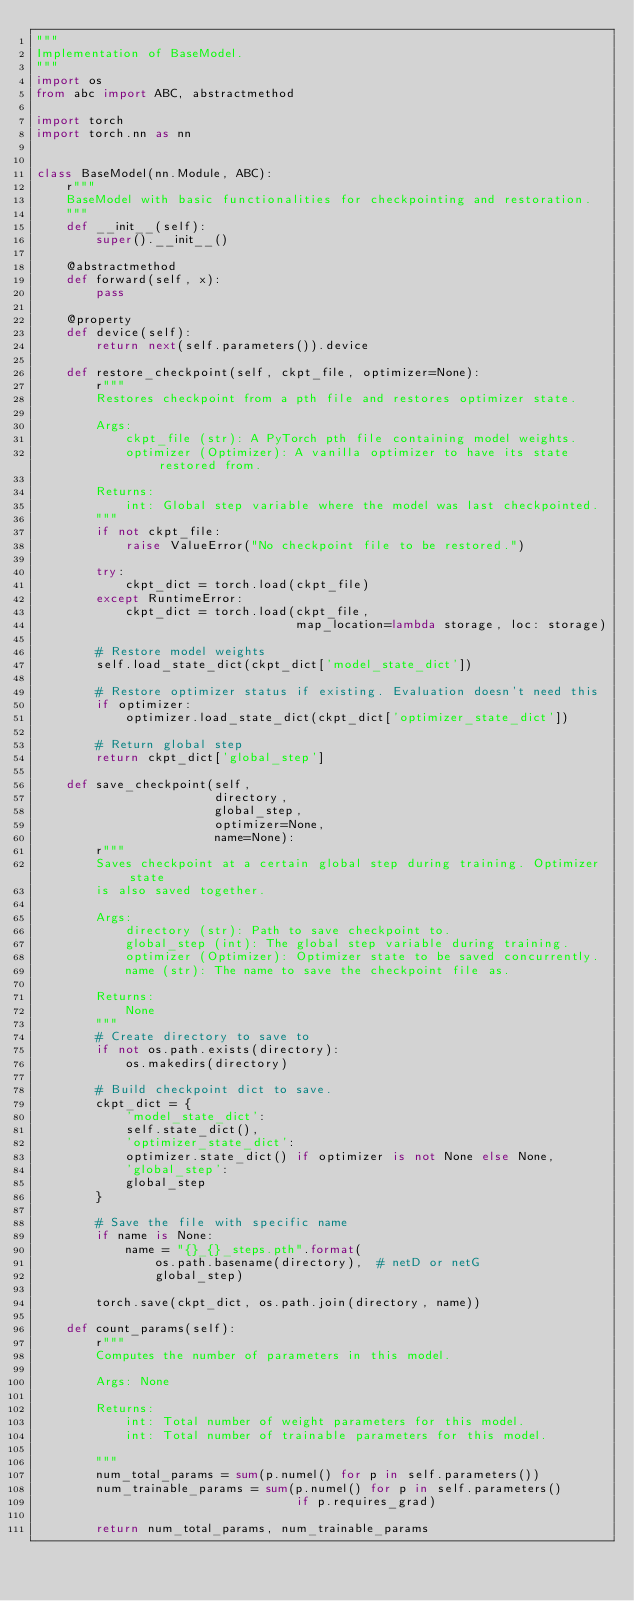<code> <loc_0><loc_0><loc_500><loc_500><_Python_>"""
Implementation of BaseModel.
"""
import os
from abc import ABC, abstractmethod

import torch
import torch.nn as nn


class BaseModel(nn.Module, ABC):
    r"""
    BaseModel with basic functionalities for checkpointing and restoration.
    """
    def __init__(self):
        super().__init__()

    @abstractmethod
    def forward(self, x):
        pass

    @property
    def device(self):
        return next(self.parameters()).device

    def restore_checkpoint(self, ckpt_file, optimizer=None):
        r"""
        Restores checkpoint from a pth file and restores optimizer state.

        Args:
            ckpt_file (str): A PyTorch pth file containing model weights.
            optimizer (Optimizer): A vanilla optimizer to have its state restored from.

        Returns:
            int: Global step variable where the model was last checkpointed.
        """
        if not ckpt_file:
            raise ValueError("No checkpoint file to be restored.")

        try:
            ckpt_dict = torch.load(ckpt_file)
        except RuntimeError:
            ckpt_dict = torch.load(ckpt_file,
                                   map_location=lambda storage, loc: storage)

        # Restore model weights
        self.load_state_dict(ckpt_dict['model_state_dict'])

        # Restore optimizer status if existing. Evaluation doesn't need this
        if optimizer:
            optimizer.load_state_dict(ckpt_dict['optimizer_state_dict'])

        # Return global step
        return ckpt_dict['global_step']

    def save_checkpoint(self,
                        directory,
                        global_step,
                        optimizer=None,
                        name=None):
        r"""
        Saves checkpoint at a certain global step during training. Optimizer state
        is also saved together.

        Args:
            directory (str): Path to save checkpoint to.
            global_step (int): The global step variable during training.
            optimizer (Optimizer): Optimizer state to be saved concurrently.
            name (str): The name to save the checkpoint file as.

        Returns:
            None
        """
        # Create directory to save to
        if not os.path.exists(directory):
            os.makedirs(directory)

        # Build checkpoint dict to save.
        ckpt_dict = {
            'model_state_dict':
            self.state_dict(),
            'optimizer_state_dict':
            optimizer.state_dict() if optimizer is not None else None,
            'global_step':
            global_step
        }

        # Save the file with specific name
        if name is None:
            name = "{}_{}_steps.pth".format(
                os.path.basename(directory),  # netD or netG
                global_step)

        torch.save(ckpt_dict, os.path.join(directory, name))

    def count_params(self):
        r"""
        Computes the number of parameters in this model.

        Args: None

        Returns:
            int: Total number of weight parameters for this model.
            int: Total number of trainable parameters for this model.

        """
        num_total_params = sum(p.numel() for p in self.parameters())
        num_trainable_params = sum(p.numel() for p in self.parameters()
                                   if p.requires_grad)

        return num_total_params, num_trainable_params
</code> 